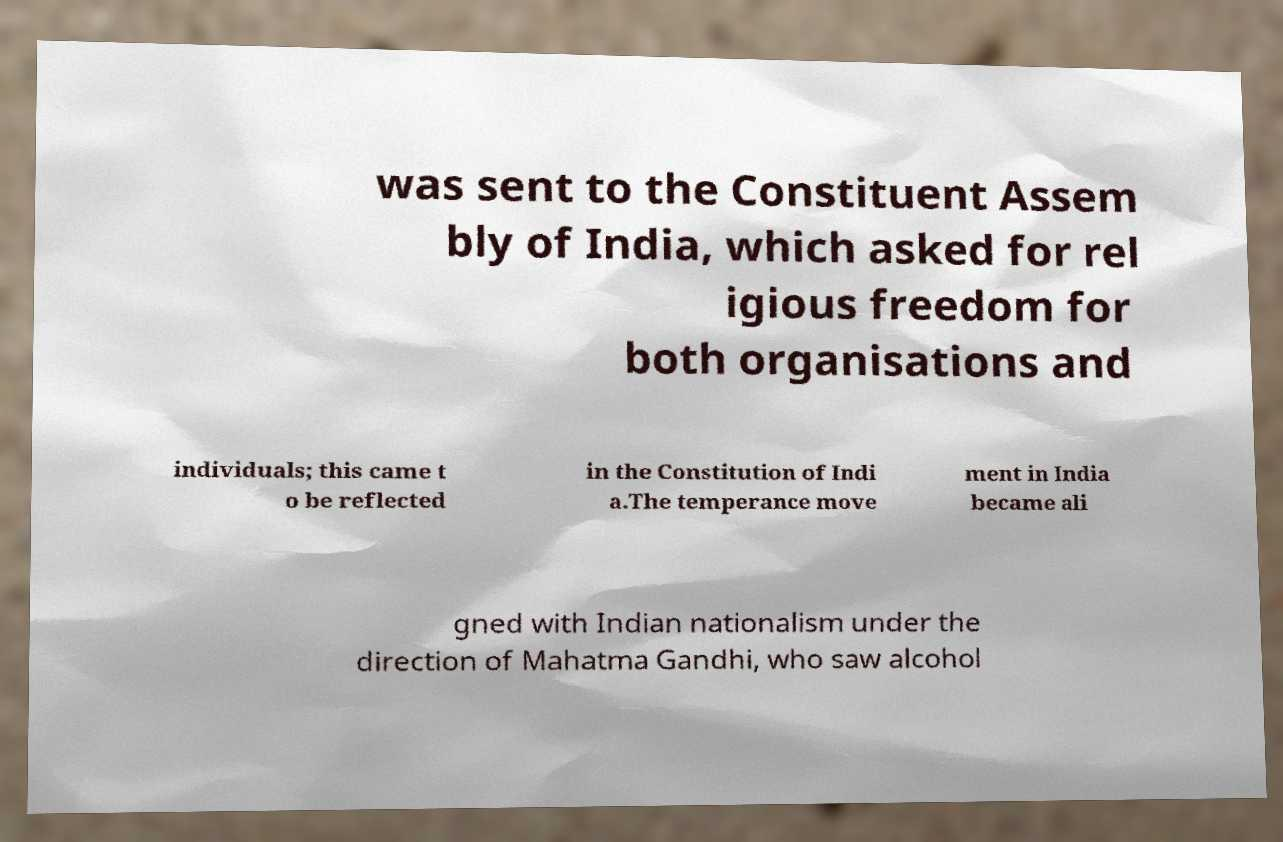For documentation purposes, I need the text within this image transcribed. Could you provide that? was sent to the Constituent Assem bly of India, which asked for rel igious freedom for both organisations and individuals; this came t o be reflected in the Constitution of Indi a.The temperance move ment in India became ali gned with Indian nationalism under the direction of Mahatma Gandhi, who saw alcohol 